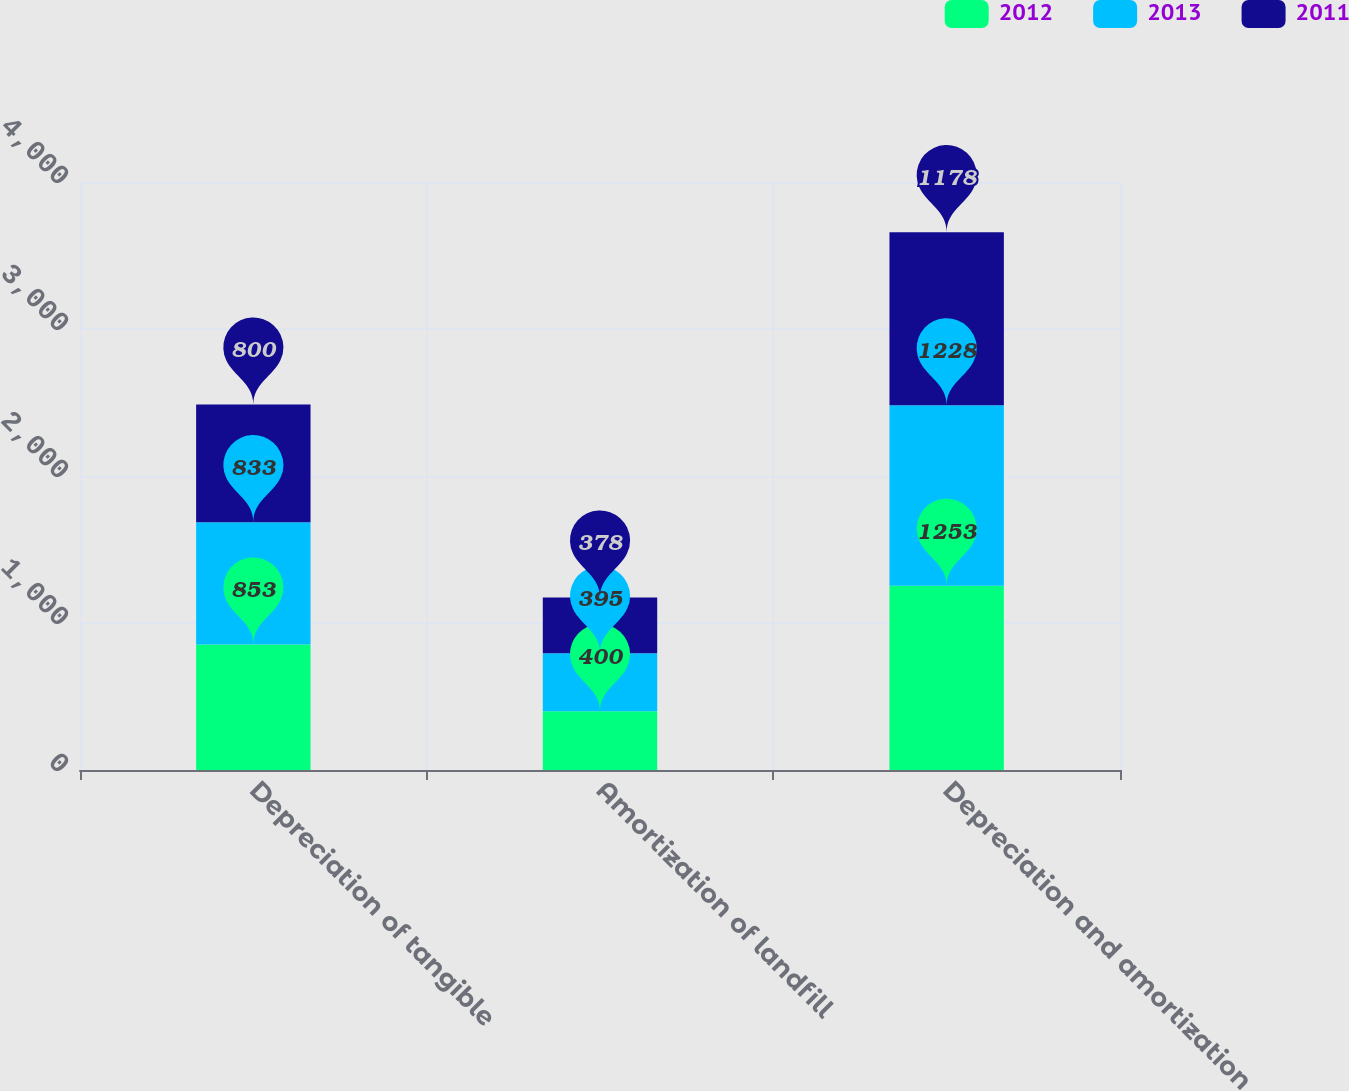Convert chart. <chart><loc_0><loc_0><loc_500><loc_500><stacked_bar_chart><ecel><fcel>Depreciation of tangible<fcel>Amortization of landfill<fcel>Depreciation and amortization<nl><fcel>2012<fcel>853<fcel>400<fcel>1253<nl><fcel>2013<fcel>833<fcel>395<fcel>1228<nl><fcel>2011<fcel>800<fcel>378<fcel>1178<nl></chart> 